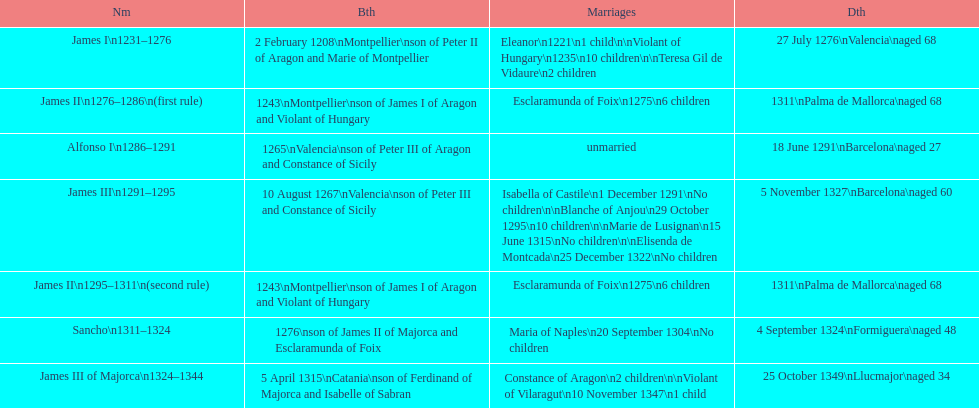James i and james ii both died at what age? 68. 